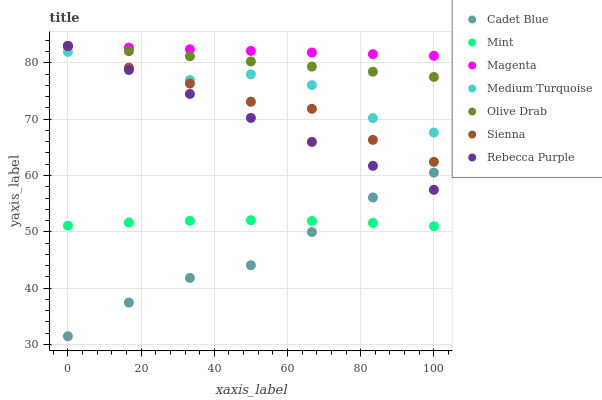Does Cadet Blue have the minimum area under the curve?
Answer yes or no. Yes. Does Magenta have the maximum area under the curve?
Answer yes or no. Yes. Does Sienna have the minimum area under the curve?
Answer yes or no. No. Does Sienna have the maximum area under the curve?
Answer yes or no. No. Is Olive Drab the smoothest?
Answer yes or no. Yes. Is Medium Turquoise the roughest?
Answer yes or no. Yes. Is Sienna the smoothest?
Answer yes or no. No. Is Sienna the roughest?
Answer yes or no. No. Does Cadet Blue have the lowest value?
Answer yes or no. Yes. Does Sienna have the lowest value?
Answer yes or no. No. Does Olive Drab have the highest value?
Answer yes or no. Yes. Does Medium Turquoise have the highest value?
Answer yes or no. No. Is Cadet Blue less than Sienna?
Answer yes or no. Yes. Is Olive Drab greater than Mint?
Answer yes or no. Yes. Does Mint intersect Cadet Blue?
Answer yes or no. Yes. Is Mint less than Cadet Blue?
Answer yes or no. No. Is Mint greater than Cadet Blue?
Answer yes or no. No. Does Cadet Blue intersect Sienna?
Answer yes or no. No. 